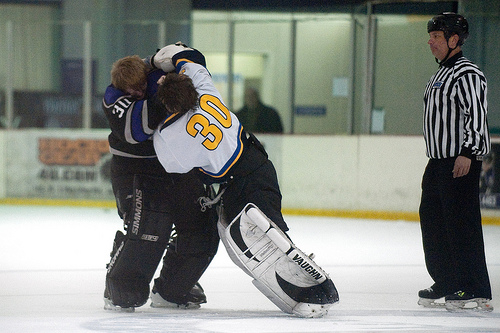<image>
Can you confirm if the referee is on the ice? Yes. Looking at the image, I can see the referee is positioned on top of the ice, with the ice providing support. Where is the man in relation to the window? Is it behind the window? No. The man is not behind the window. From this viewpoint, the man appears to be positioned elsewhere in the scene. 